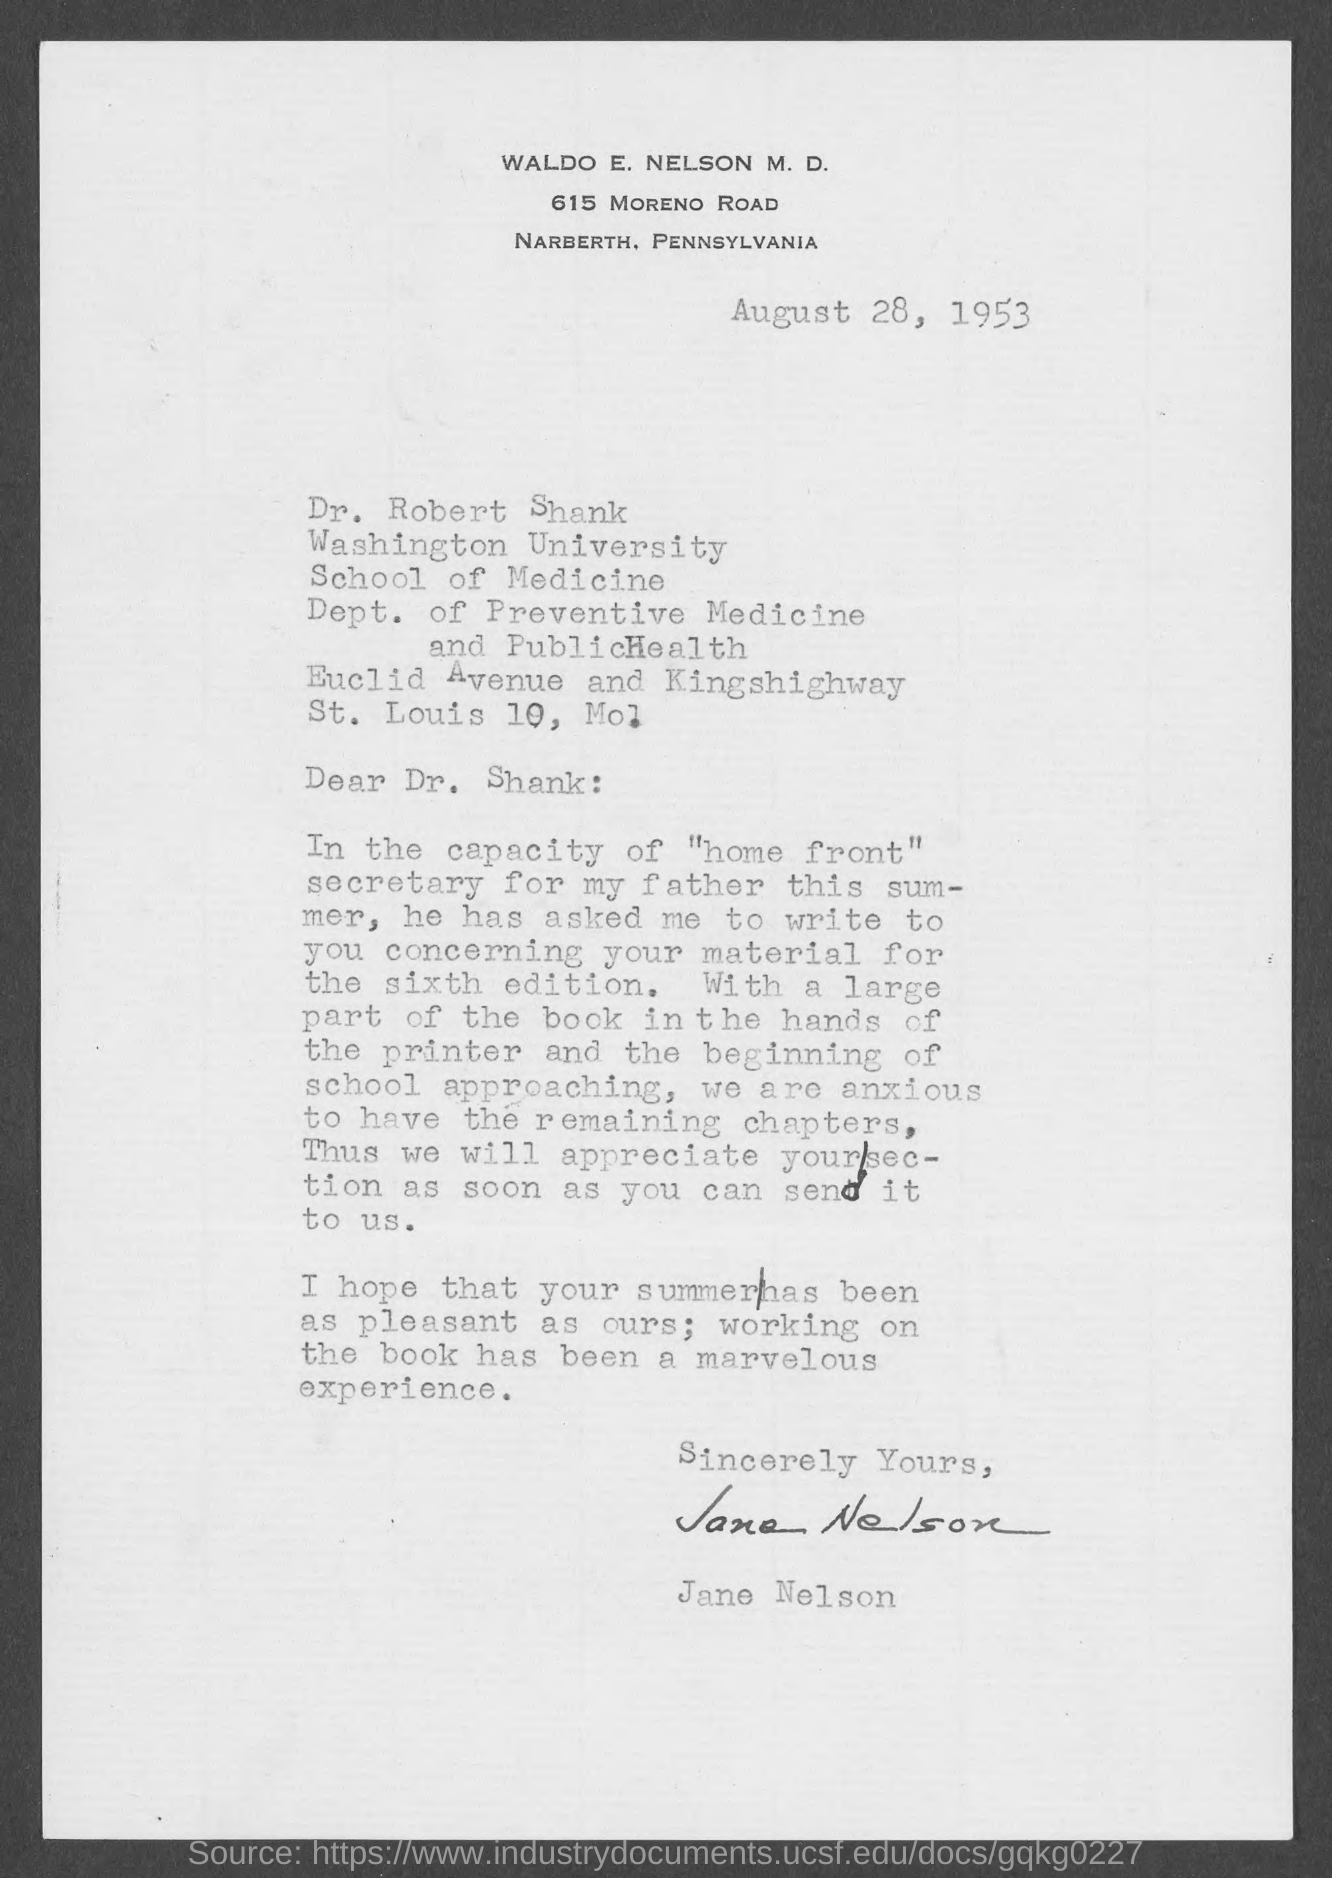Identify some key points in this picture. The letter is addressed to Dr. Robert Shank. Jane Nelson has signed the letter. The document is dated August 28, 1953. 